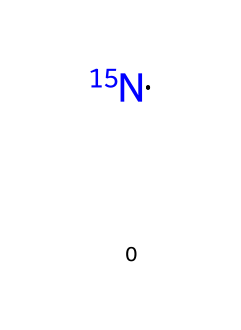What is the atomic mass of nitrogen-15? The atomic mass of nitrogen-15 is defined by the number of protons and neutrons it contains. Nitrogen has 7 protons and since it is nitrogen-15, it has 15 - 7 = 8 neutrons. Thus, the atomic mass is 15.
Answer: 15 How many neutrons are present in nitrogen-15? To find the number of neutrons, we can subtract the number of protons from the atomic mass. Nitrogen has 7 protons, and nitrogen-15 has an atomic mass of 15. Therefore, there are 15 - 7 = 8 neutrons.
Answer: 8 Is nitrogen-15 a stable isotope? Stability in isotopes is often characterized by having a balanced ratio of protons to neutrons. Nitrogen-15, with its 7 protons and 8 neutrons, has a stable ratio, meaning it is not radioactive.
Answer: Yes What role does nitrogen-15 play in protein metabolism tracking? Nitrogen-15 is used as a tracer in metabolic studies to monitor nitrogen incorporation in proteins, allowing scientists to analyze protein synthesis and breakdown.
Answer: Tracer What is the natural abundance of nitrogen-15 in the atmosphere? The natural abundance refers to the proportion of nitrogen-15 relative to other isotopes of nitrogen. Nitrogen-15 constitutes about 0.36% of natural nitrogen in the atmosphere.
Answer: 0.36% Which element is nitrogen-15 associated with in biological systems? In biological systems, nitrogen-15 is primarily associated with proteins, as proteins are composed of amino acids that contain nitrogen. This links nitrogen-15 to protein analysis.
Answer: Proteins 